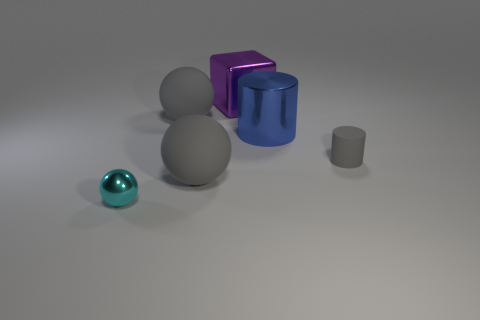Is the number of blue shiny cylinders that are in front of the large blue cylinder less than the number of gray spheres?
Provide a short and direct response. Yes. Does the tiny cylinder have the same material as the cyan object?
Provide a short and direct response. No. How many things are either large gray things that are in front of the gray cylinder or matte things right of the blue thing?
Your response must be concise. 2. Are there any red metal balls that have the same size as the purple cube?
Ensure brevity in your answer.  No. What is the color of the other thing that is the same shape as the big blue metallic object?
Provide a short and direct response. Gray. Are there any big things on the right side of the gray matte ball in front of the tiny matte thing?
Your answer should be compact. Yes. Does the big object that is to the right of the purple object have the same shape as the purple shiny object?
Offer a terse response. No. The tiny cyan object is what shape?
Offer a terse response. Sphere. What number of large blocks are the same material as the blue cylinder?
Offer a terse response. 1. Do the rubber cylinder and the big matte sphere that is in front of the blue metal cylinder have the same color?
Provide a succinct answer. Yes. 